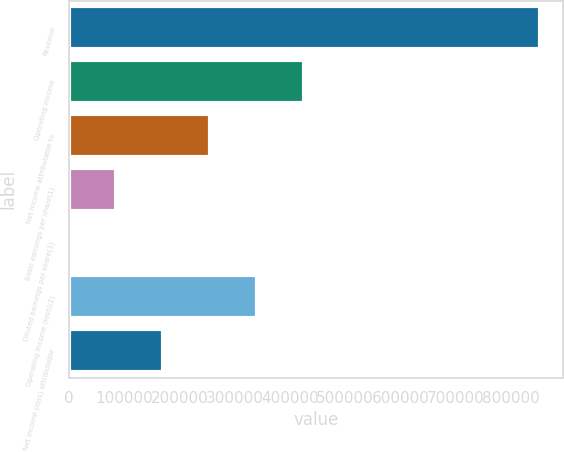<chart> <loc_0><loc_0><loc_500><loc_500><bar_chart><fcel>Revenue<fcel>Operating income<fcel>Net income attributable to<fcel>Basic earnings per share(1)<fcel>Diluted earnings per share(1)<fcel>Operating income (loss)(2)<fcel>Net income (loss) attributable<nl><fcel>852428<fcel>426214<fcel>255729<fcel>85243.2<fcel>0.4<fcel>340971<fcel>170486<nl></chart> 